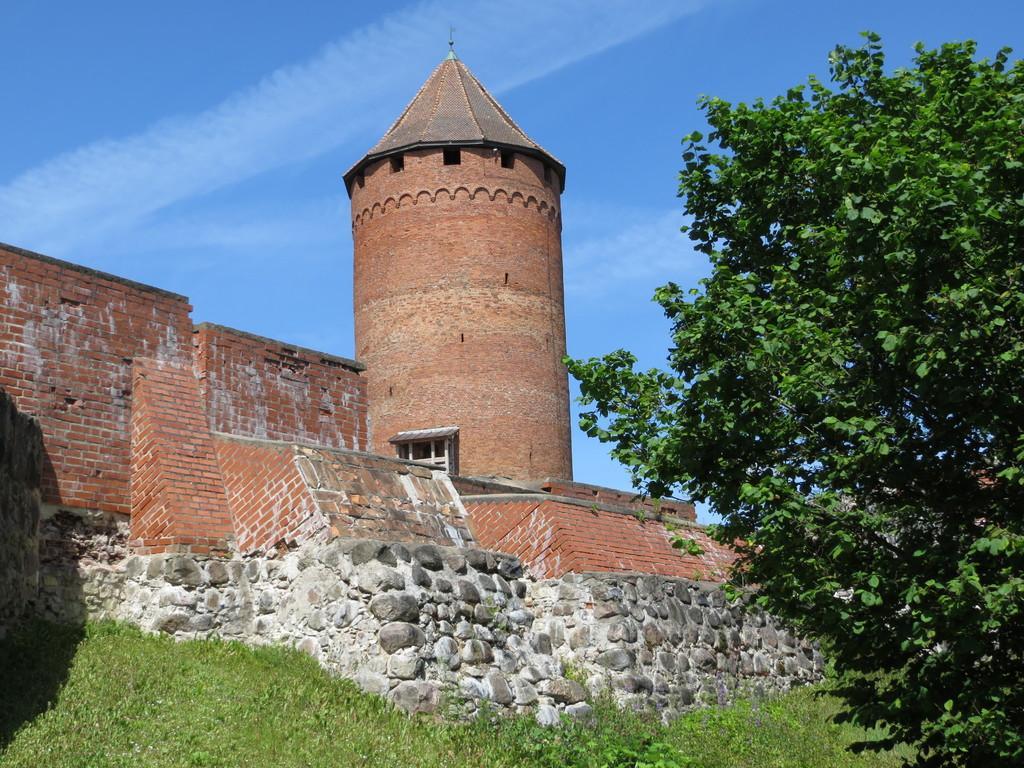Describe this image in one or two sentences. In this image we can see a building, walls, grass, plants, and trees. In the background there is sky. 